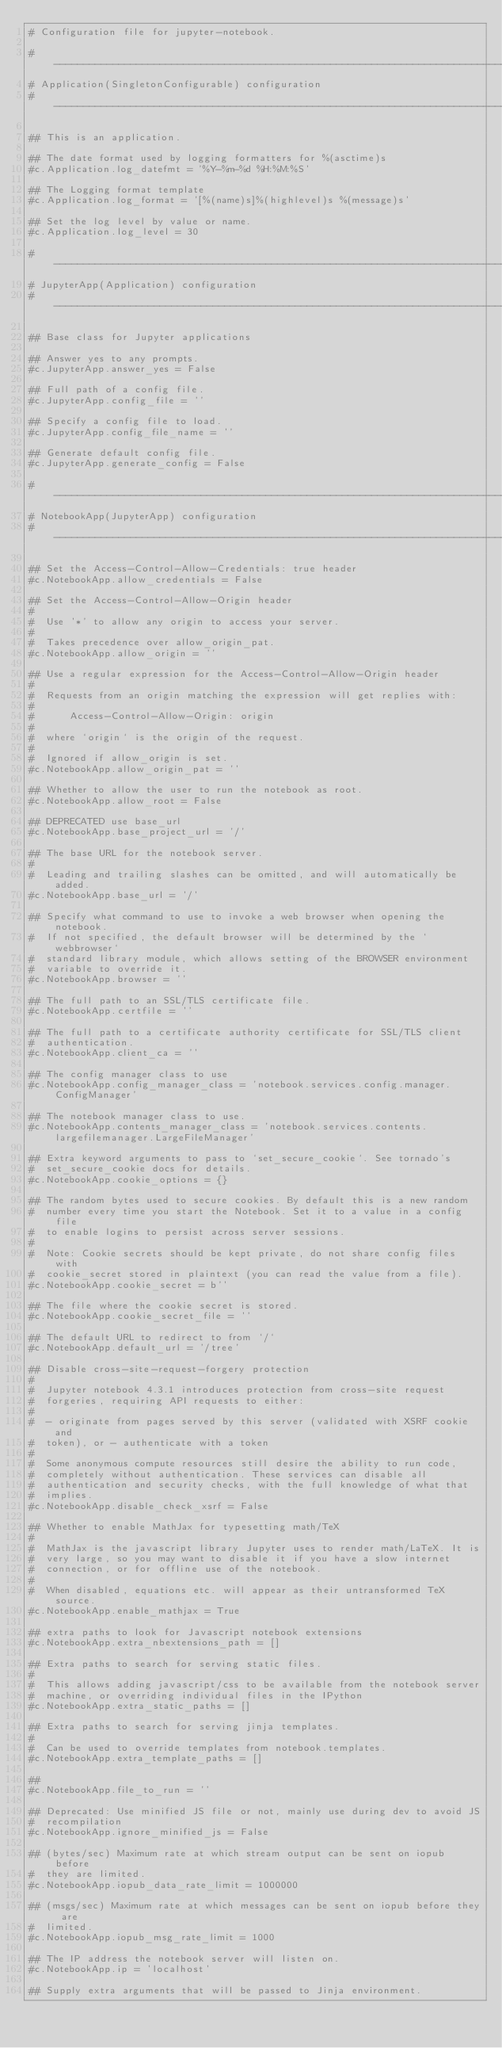Convert code to text. <code><loc_0><loc_0><loc_500><loc_500><_Python_># Configuration file for jupyter-notebook.

#------------------------------------------------------------------------------
# Application(SingletonConfigurable) configuration
#------------------------------------------------------------------------------

## This is an application.

## The date format used by logging formatters for %(asctime)s
#c.Application.log_datefmt = '%Y-%m-%d %H:%M:%S'

## The Logging format template
#c.Application.log_format = '[%(name)s]%(highlevel)s %(message)s'

## Set the log level by value or name.
#c.Application.log_level = 30

#------------------------------------------------------------------------------
# JupyterApp(Application) configuration
#------------------------------------------------------------------------------

## Base class for Jupyter applications

## Answer yes to any prompts.
#c.JupyterApp.answer_yes = False

## Full path of a config file.
#c.JupyterApp.config_file = ''

## Specify a config file to load.
#c.JupyterApp.config_file_name = ''

## Generate default config file.
#c.JupyterApp.generate_config = False

#------------------------------------------------------------------------------
# NotebookApp(JupyterApp) configuration
#------------------------------------------------------------------------------

## Set the Access-Control-Allow-Credentials: true header
#c.NotebookApp.allow_credentials = False

## Set the Access-Control-Allow-Origin header
#
#  Use '*' to allow any origin to access your server.
#
#  Takes precedence over allow_origin_pat.
#c.NotebookApp.allow_origin = ''

## Use a regular expression for the Access-Control-Allow-Origin header
#
#  Requests from an origin matching the expression will get replies with:
#
#      Access-Control-Allow-Origin: origin
#
#  where `origin` is the origin of the request.
#
#  Ignored if allow_origin is set.
#c.NotebookApp.allow_origin_pat = ''

## Whether to allow the user to run the notebook as root.
#c.NotebookApp.allow_root = False

## DEPRECATED use base_url
#c.NotebookApp.base_project_url = '/'

## The base URL for the notebook server.
#
#  Leading and trailing slashes can be omitted, and will automatically be added.
#c.NotebookApp.base_url = '/'

## Specify what command to use to invoke a web browser when opening the notebook.
#  If not specified, the default browser will be determined by the `webbrowser`
#  standard library module, which allows setting of the BROWSER environment
#  variable to override it.
#c.NotebookApp.browser = ''

## The full path to an SSL/TLS certificate file.
#c.NotebookApp.certfile = ''

## The full path to a certificate authority certificate for SSL/TLS client
#  authentication.
#c.NotebookApp.client_ca = ''

## The config manager class to use
#c.NotebookApp.config_manager_class = 'notebook.services.config.manager.ConfigManager'

## The notebook manager class to use.
#c.NotebookApp.contents_manager_class = 'notebook.services.contents.largefilemanager.LargeFileManager'

## Extra keyword arguments to pass to `set_secure_cookie`. See tornado's
#  set_secure_cookie docs for details.
#c.NotebookApp.cookie_options = {}

## The random bytes used to secure cookies. By default this is a new random
#  number every time you start the Notebook. Set it to a value in a config file
#  to enable logins to persist across server sessions.
#
#  Note: Cookie secrets should be kept private, do not share config files with
#  cookie_secret stored in plaintext (you can read the value from a file).
#c.NotebookApp.cookie_secret = b''

## The file where the cookie secret is stored.
#c.NotebookApp.cookie_secret_file = ''

## The default URL to redirect to from `/`
#c.NotebookApp.default_url = '/tree'

## Disable cross-site-request-forgery protection
#
#  Jupyter notebook 4.3.1 introduces protection from cross-site request
#  forgeries, requiring API requests to either:
#
#  - originate from pages served by this server (validated with XSRF cookie and
#  token), or - authenticate with a token
#
#  Some anonymous compute resources still desire the ability to run code,
#  completely without authentication. These services can disable all
#  authentication and security checks, with the full knowledge of what that
#  implies.
#c.NotebookApp.disable_check_xsrf = False

## Whether to enable MathJax for typesetting math/TeX
#
#  MathJax is the javascript library Jupyter uses to render math/LaTeX. It is
#  very large, so you may want to disable it if you have a slow internet
#  connection, or for offline use of the notebook.
#
#  When disabled, equations etc. will appear as their untransformed TeX source.
#c.NotebookApp.enable_mathjax = True

## extra paths to look for Javascript notebook extensions
#c.NotebookApp.extra_nbextensions_path = []

## Extra paths to search for serving static files.
#
#  This allows adding javascript/css to be available from the notebook server
#  machine, or overriding individual files in the IPython
#c.NotebookApp.extra_static_paths = []

## Extra paths to search for serving jinja templates.
#
#  Can be used to override templates from notebook.templates.
#c.NotebookApp.extra_template_paths = []

##
#c.NotebookApp.file_to_run = ''

## Deprecated: Use minified JS file or not, mainly use during dev to avoid JS
#  recompilation
#c.NotebookApp.ignore_minified_js = False

## (bytes/sec) Maximum rate at which stream output can be sent on iopub before
#  they are limited.
#c.NotebookApp.iopub_data_rate_limit = 1000000

## (msgs/sec) Maximum rate at which messages can be sent on iopub before they are
#  limited.
#c.NotebookApp.iopub_msg_rate_limit = 1000

## The IP address the notebook server will listen on.
#c.NotebookApp.ip = 'localhost'

## Supply extra arguments that will be passed to Jinja environment.</code> 